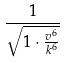Convert formula to latex. <formula><loc_0><loc_0><loc_500><loc_500>\frac { 1 } { \sqrt { 1 \cdot \frac { v ^ { 6 } } { k ^ { 6 } } } }</formula> 